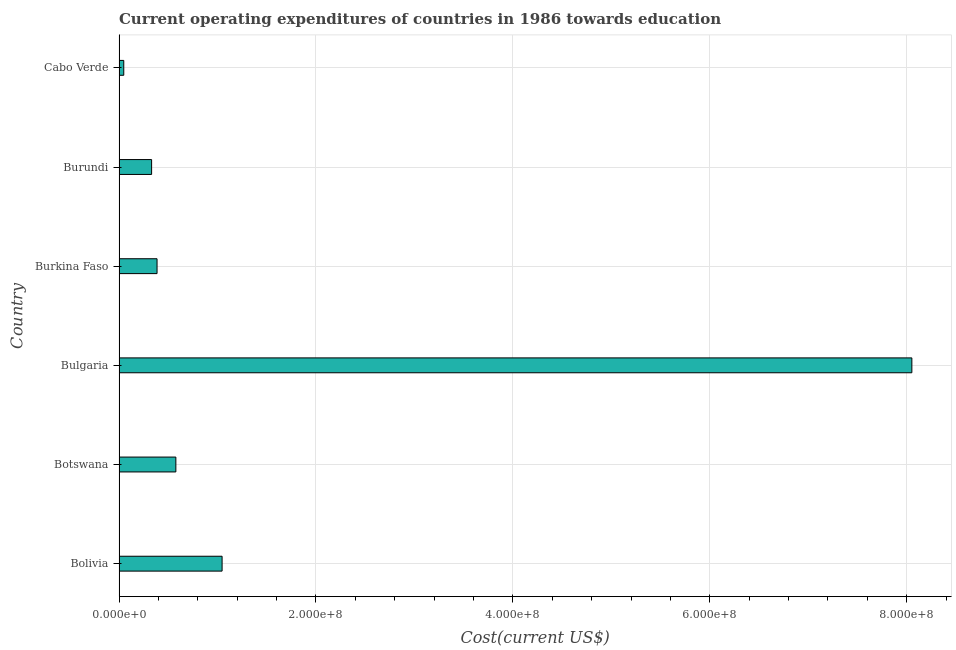Does the graph contain grids?
Your answer should be very brief. Yes. What is the title of the graph?
Keep it short and to the point. Current operating expenditures of countries in 1986 towards education. What is the label or title of the X-axis?
Keep it short and to the point. Cost(current US$). What is the label or title of the Y-axis?
Keep it short and to the point. Country. What is the education expenditure in Botswana?
Your answer should be compact. 5.77e+07. Across all countries, what is the maximum education expenditure?
Your answer should be compact. 8.05e+08. Across all countries, what is the minimum education expenditure?
Ensure brevity in your answer.  4.79e+06. In which country was the education expenditure maximum?
Your response must be concise. Bulgaria. In which country was the education expenditure minimum?
Provide a succinct answer. Cabo Verde. What is the sum of the education expenditure?
Give a very brief answer. 1.04e+09. What is the difference between the education expenditure in Botswana and Cabo Verde?
Ensure brevity in your answer.  5.29e+07. What is the average education expenditure per country?
Provide a succinct answer. 1.74e+08. What is the median education expenditure?
Make the answer very short. 4.81e+07. In how many countries, is the education expenditure greater than 440000000 US$?
Provide a short and direct response. 1. What is the ratio of the education expenditure in Bolivia to that in Bulgaria?
Your answer should be very brief. 0.13. Is the difference between the education expenditure in Bolivia and Burundi greater than the difference between any two countries?
Your answer should be compact. No. What is the difference between the highest and the second highest education expenditure?
Provide a short and direct response. 7.01e+08. What is the difference between the highest and the lowest education expenditure?
Your response must be concise. 8.00e+08. Are all the bars in the graph horizontal?
Your answer should be very brief. Yes. How many countries are there in the graph?
Offer a terse response. 6. Are the values on the major ticks of X-axis written in scientific E-notation?
Provide a succinct answer. Yes. What is the Cost(current US$) of Bolivia?
Offer a terse response. 1.05e+08. What is the Cost(current US$) of Botswana?
Your answer should be compact. 5.77e+07. What is the Cost(current US$) of Bulgaria?
Ensure brevity in your answer.  8.05e+08. What is the Cost(current US$) of Burkina Faso?
Keep it short and to the point. 3.86e+07. What is the Cost(current US$) in Burundi?
Give a very brief answer. 3.31e+07. What is the Cost(current US$) of Cabo Verde?
Your answer should be compact. 4.79e+06. What is the difference between the Cost(current US$) in Bolivia and Botswana?
Offer a terse response. 4.70e+07. What is the difference between the Cost(current US$) in Bolivia and Bulgaria?
Ensure brevity in your answer.  -7.01e+08. What is the difference between the Cost(current US$) in Bolivia and Burkina Faso?
Your answer should be very brief. 6.61e+07. What is the difference between the Cost(current US$) in Bolivia and Burundi?
Make the answer very short. 7.16e+07. What is the difference between the Cost(current US$) in Bolivia and Cabo Verde?
Give a very brief answer. 9.99e+07. What is the difference between the Cost(current US$) in Botswana and Bulgaria?
Ensure brevity in your answer.  -7.47e+08. What is the difference between the Cost(current US$) in Botswana and Burkina Faso?
Provide a short and direct response. 1.91e+07. What is the difference between the Cost(current US$) in Botswana and Burundi?
Your response must be concise. 2.46e+07. What is the difference between the Cost(current US$) in Botswana and Cabo Verde?
Keep it short and to the point. 5.29e+07. What is the difference between the Cost(current US$) in Bulgaria and Burkina Faso?
Keep it short and to the point. 7.67e+08. What is the difference between the Cost(current US$) in Bulgaria and Burundi?
Provide a succinct answer. 7.72e+08. What is the difference between the Cost(current US$) in Bulgaria and Cabo Verde?
Offer a very short reply. 8.00e+08. What is the difference between the Cost(current US$) in Burkina Faso and Burundi?
Your answer should be compact. 5.52e+06. What is the difference between the Cost(current US$) in Burkina Faso and Cabo Verde?
Provide a succinct answer. 3.38e+07. What is the difference between the Cost(current US$) in Burundi and Cabo Verde?
Ensure brevity in your answer.  2.83e+07. What is the ratio of the Cost(current US$) in Bolivia to that in Botswana?
Keep it short and to the point. 1.81. What is the ratio of the Cost(current US$) in Bolivia to that in Bulgaria?
Offer a very short reply. 0.13. What is the ratio of the Cost(current US$) in Bolivia to that in Burkina Faso?
Your answer should be very brief. 2.71. What is the ratio of the Cost(current US$) in Bolivia to that in Burundi?
Provide a short and direct response. 3.16. What is the ratio of the Cost(current US$) in Bolivia to that in Cabo Verde?
Keep it short and to the point. 21.83. What is the ratio of the Cost(current US$) in Botswana to that in Bulgaria?
Your answer should be compact. 0.07. What is the ratio of the Cost(current US$) in Botswana to that in Burkina Faso?
Your answer should be very brief. 1.5. What is the ratio of the Cost(current US$) in Botswana to that in Burundi?
Give a very brief answer. 1.75. What is the ratio of the Cost(current US$) in Botswana to that in Cabo Verde?
Provide a succinct answer. 12.04. What is the ratio of the Cost(current US$) in Bulgaria to that in Burkina Faso?
Ensure brevity in your answer.  20.87. What is the ratio of the Cost(current US$) in Bulgaria to that in Burundi?
Offer a very short reply. 24.35. What is the ratio of the Cost(current US$) in Bulgaria to that in Cabo Verde?
Your response must be concise. 167.99. What is the ratio of the Cost(current US$) in Burkina Faso to that in Burundi?
Provide a short and direct response. 1.17. What is the ratio of the Cost(current US$) in Burkina Faso to that in Cabo Verde?
Keep it short and to the point. 8.05. 